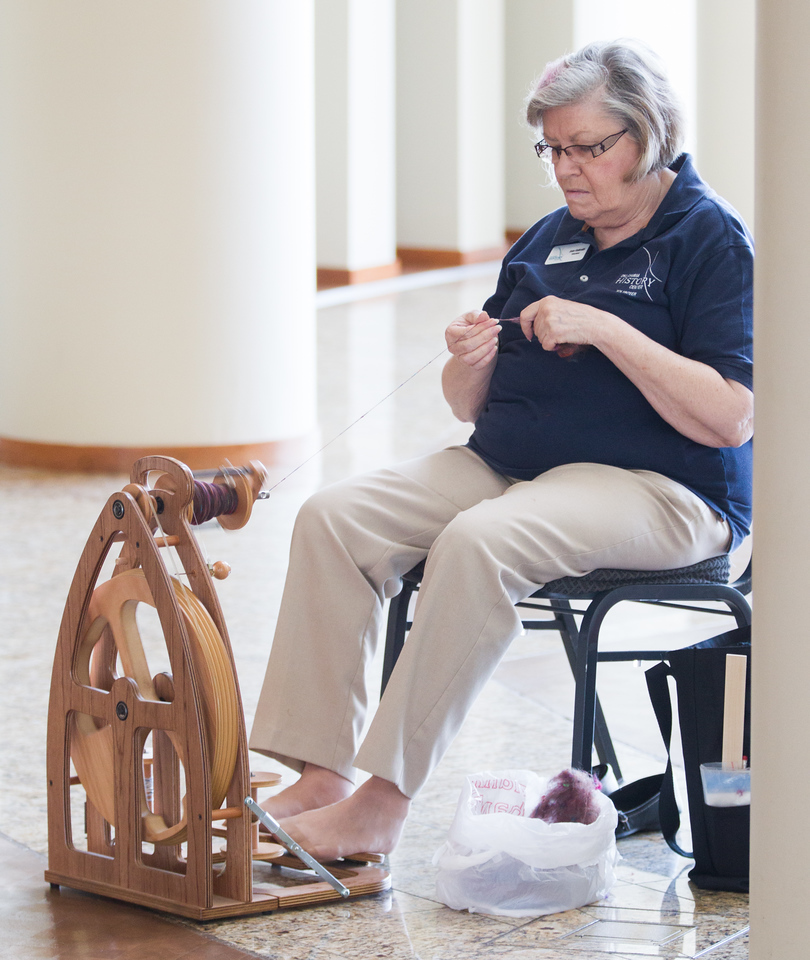What kind of environment is she in, and how might it affect her craft? The woman appears to be in a calm, indoor environment with ample natural light, which is conducive to spinning yarn. This setting likely provides minimal distractions, allowing her to focus on the intricate task of spinning. The spacious and clean surroundings also imply that she has enough room to store her materials and tools in an orderly manner, supporting the precision needed in her craft. Additionally, the controlled climate indoors ensures that the yarn and fibers maintain their quality without exposure to outdoor elements like humidity or dust. What are the benefits of spinning yarn in natural light? Spinning yarn in natural light offers several benefits. Firstly, it allows for better visibility of the fibers, helping the spinner to detect and correct any inconsistencies in the yarn. Natural light also enhances the ability to discern the true colors of the fibers, which is crucial for projects that require precise color matching. Moreover, working in natural light can reduce eye strain and fatigue, making the spinning process more comfortable and sustainable over long periods. Overall, it creates a pleasant and conducive working environment, which can enhance both the quality and enjoyment of the craft. Imagine she could be creating stories with the yarn. What kind of stories might they tell? If the yarn she's spinning could be woven into stories, they might tell tales of old-world artisans working diligently by candlelight, creating garments that warm hearts and bodies. Perhaps the yarn would whisper myths of mythical creatures living within the fibers, each thread holding secrets of the past, and dreams of the future. As she spins, it could narrate the journeys of people across lands and cultures, depicting the intricate dance of life through the twists and turns of the yarn. Her hands might be crafting not just fabric, but the tapestry of human experience, rich in color and texture, each length of yarn a chapter in a grand, interconnected story. What might be a realistic scenario in which she is teaching someone to spin yarn? In a cozy, well-lit room filled with various fibers and tools, the woman patiently demonstrates the art of spinning yarn to a novice. She begins with the basics, explaining the different types of fibers and their properties. Slowly, she guides her student through the process of preparing the fiber, showing how to card and align the fibers for smooth spinning. With a gentle hand, she sits beside them at the spinning wheel, offering tips and encouragement. As the student makes their first attempts, she provides expert feedback, sharing her knowledge gained through years of practice, fostering a warm and supportive learning environment. Describe a short scenario where she spins yarn for herself. One quiet afternoon, the woman sits by her spinning wheel, listening to the soft hum as she works. The natural light streaming through the window highlights the fibers in her hand. She feels a deep sense of calm and satisfaction as she watches the yarn steadily form on the bobbin, lost in the rhythm of the wheel and the serenity of her craft. 